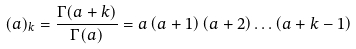<formula> <loc_0><loc_0><loc_500><loc_500>( a ) _ { k } = \frac { \Gamma ( a + k ) } { \Gamma ( a ) } = a \left ( a + 1 \right ) \left ( a + 2 \right ) \dots \left ( a + k - 1 \right )</formula> 